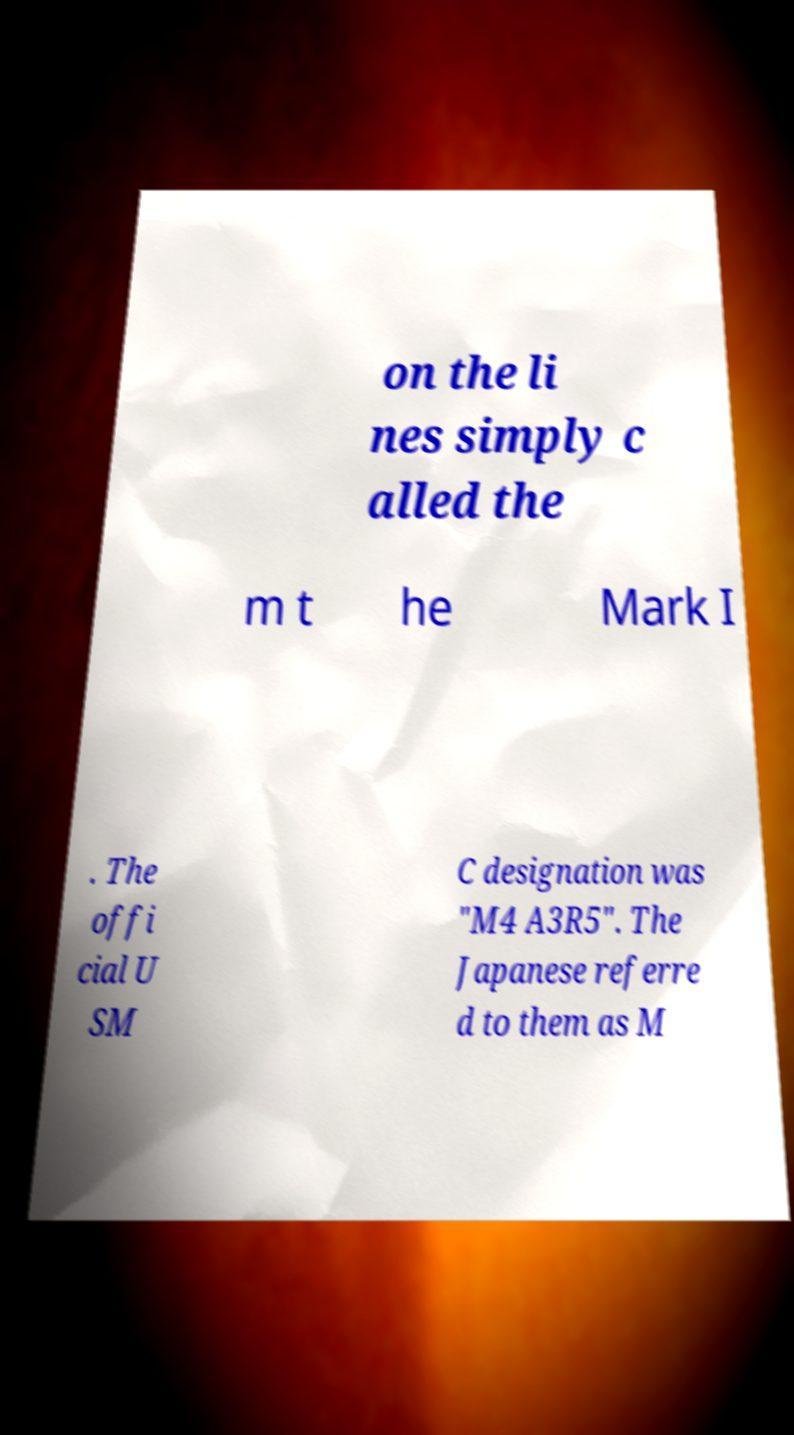What messages or text are displayed in this image? I need them in a readable, typed format. on the li nes simply c alled the m t he Mark I . The offi cial U SM C designation was "M4 A3R5". The Japanese referre d to them as M 